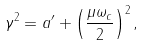<formula> <loc_0><loc_0><loc_500><loc_500>\gamma ^ { 2 } = a ^ { \prime } + \left ( \frac { \mu \omega _ { c } } { 2 } \right ) ^ { 2 } ,</formula> 